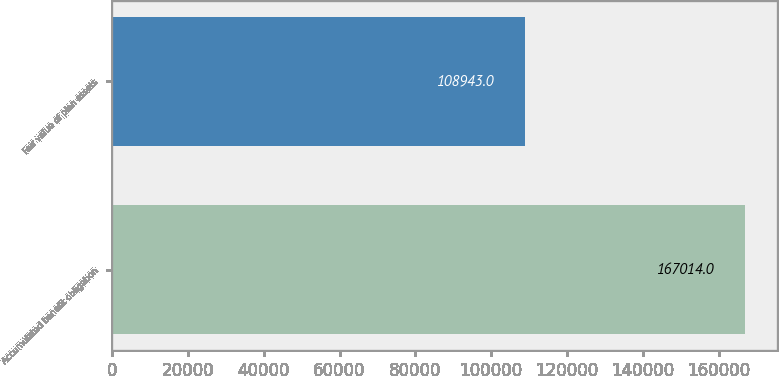Convert chart. <chart><loc_0><loc_0><loc_500><loc_500><bar_chart><fcel>Accumulated benefit obligation<fcel>Fair value of plan assets<nl><fcel>167014<fcel>108943<nl></chart> 